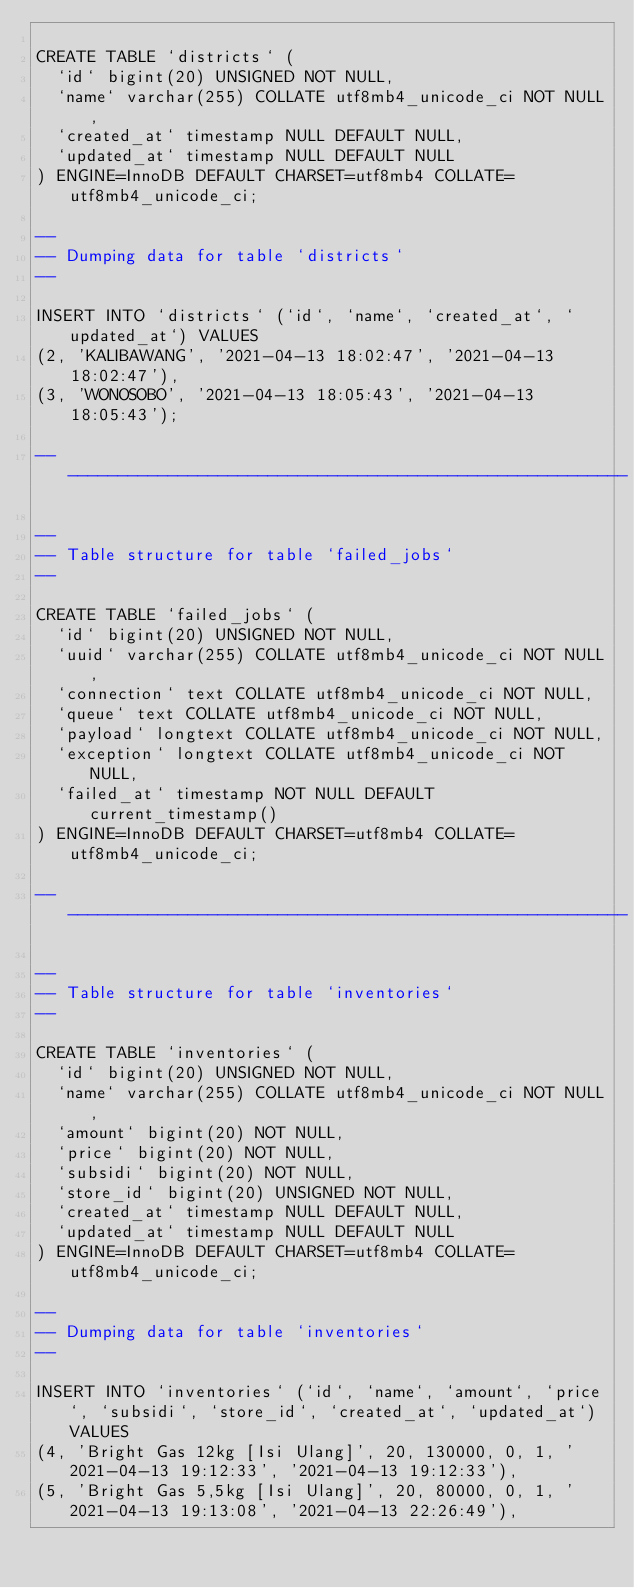Convert code to text. <code><loc_0><loc_0><loc_500><loc_500><_SQL_>
CREATE TABLE `districts` (
  `id` bigint(20) UNSIGNED NOT NULL,
  `name` varchar(255) COLLATE utf8mb4_unicode_ci NOT NULL,
  `created_at` timestamp NULL DEFAULT NULL,
  `updated_at` timestamp NULL DEFAULT NULL
) ENGINE=InnoDB DEFAULT CHARSET=utf8mb4 COLLATE=utf8mb4_unicode_ci;

--
-- Dumping data for table `districts`
--

INSERT INTO `districts` (`id`, `name`, `created_at`, `updated_at`) VALUES
(2, 'KALIBAWANG', '2021-04-13 18:02:47', '2021-04-13 18:02:47'),
(3, 'WONOSOBO', '2021-04-13 18:05:43', '2021-04-13 18:05:43');

-- --------------------------------------------------------

--
-- Table structure for table `failed_jobs`
--

CREATE TABLE `failed_jobs` (
  `id` bigint(20) UNSIGNED NOT NULL,
  `uuid` varchar(255) COLLATE utf8mb4_unicode_ci NOT NULL,
  `connection` text COLLATE utf8mb4_unicode_ci NOT NULL,
  `queue` text COLLATE utf8mb4_unicode_ci NOT NULL,
  `payload` longtext COLLATE utf8mb4_unicode_ci NOT NULL,
  `exception` longtext COLLATE utf8mb4_unicode_ci NOT NULL,
  `failed_at` timestamp NOT NULL DEFAULT current_timestamp()
) ENGINE=InnoDB DEFAULT CHARSET=utf8mb4 COLLATE=utf8mb4_unicode_ci;

-- --------------------------------------------------------

--
-- Table structure for table `inventories`
--

CREATE TABLE `inventories` (
  `id` bigint(20) UNSIGNED NOT NULL,
  `name` varchar(255) COLLATE utf8mb4_unicode_ci NOT NULL,
  `amount` bigint(20) NOT NULL,
  `price` bigint(20) NOT NULL,
  `subsidi` bigint(20) NOT NULL,
  `store_id` bigint(20) UNSIGNED NOT NULL,
  `created_at` timestamp NULL DEFAULT NULL,
  `updated_at` timestamp NULL DEFAULT NULL
) ENGINE=InnoDB DEFAULT CHARSET=utf8mb4 COLLATE=utf8mb4_unicode_ci;

--
-- Dumping data for table `inventories`
--

INSERT INTO `inventories` (`id`, `name`, `amount`, `price`, `subsidi`, `store_id`, `created_at`, `updated_at`) VALUES
(4, 'Bright Gas 12kg [Isi Ulang]', 20, 130000, 0, 1, '2021-04-13 19:12:33', '2021-04-13 19:12:33'),
(5, 'Bright Gas 5,5kg [Isi Ulang]', 20, 80000, 0, 1, '2021-04-13 19:13:08', '2021-04-13 22:26:49'),</code> 